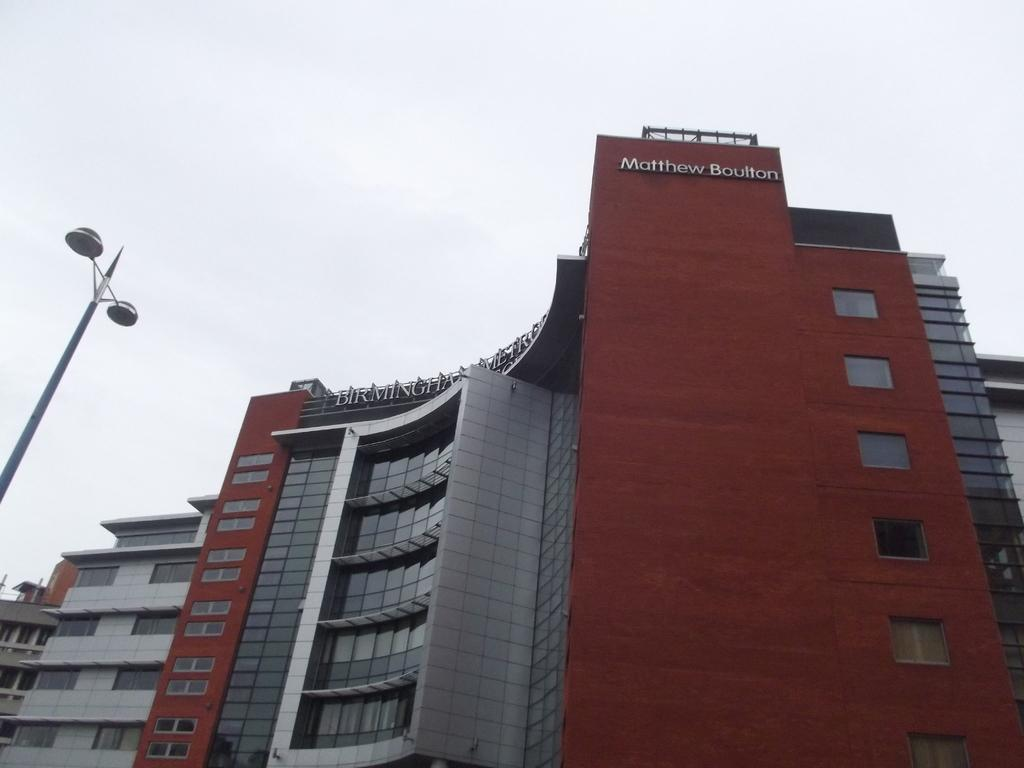What can be seen in the background of the image? There is a sky in the image. What type of structure is present in the image? There is a building in the image. What is attached to the pole in the image? There are street lights attached to the pole in the image. How many buttons are on the building in the image? There are no buttons visible on the building in the image. What type of unit is being measured by the street lights in the image? The street lights in the image are not measuring any units; they are providing illumination. 